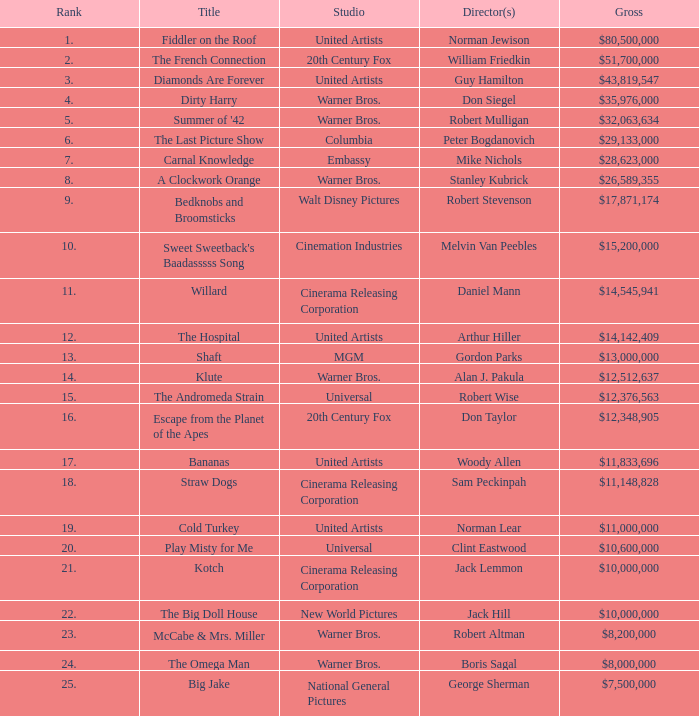What position does the big doll house hold in terms of ranking? 22.0. Give me the full table as a dictionary. {'header': ['Rank', 'Title', 'Studio', 'Director(s)', 'Gross'], 'rows': [['1.', 'Fiddler on the Roof', 'United Artists', 'Norman Jewison', '$80,500,000'], ['2.', 'The French Connection', '20th Century Fox', 'William Friedkin', '$51,700,000'], ['3.', 'Diamonds Are Forever', 'United Artists', 'Guy Hamilton', '$43,819,547'], ['4.', 'Dirty Harry', 'Warner Bros.', 'Don Siegel', '$35,976,000'], ['5.', "Summer of '42", 'Warner Bros.', 'Robert Mulligan', '$32,063,634'], ['6.', 'The Last Picture Show', 'Columbia', 'Peter Bogdanovich', '$29,133,000'], ['7.', 'Carnal Knowledge', 'Embassy', 'Mike Nichols', '$28,623,000'], ['8.', 'A Clockwork Orange', 'Warner Bros.', 'Stanley Kubrick', '$26,589,355'], ['9.', 'Bedknobs and Broomsticks', 'Walt Disney Pictures', 'Robert Stevenson', '$17,871,174'], ['10.', "Sweet Sweetback's Baadasssss Song", 'Cinemation Industries', 'Melvin Van Peebles', '$15,200,000'], ['11.', 'Willard', 'Cinerama Releasing Corporation', 'Daniel Mann', '$14,545,941'], ['12.', 'The Hospital', 'United Artists', 'Arthur Hiller', '$14,142,409'], ['13.', 'Shaft', 'MGM', 'Gordon Parks', '$13,000,000'], ['14.', 'Klute', 'Warner Bros.', 'Alan J. Pakula', '$12,512,637'], ['15.', 'The Andromeda Strain', 'Universal', 'Robert Wise', '$12,376,563'], ['16.', 'Escape from the Planet of the Apes', '20th Century Fox', 'Don Taylor', '$12,348,905'], ['17.', 'Bananas', 'United Artists', 'Woody Allen', '$11,833,696'], ['18.', 'Straw Dogs', 'Cinerama Releasing Corporation', 'Sam Peckinpah', '$11,148,828'], ['19.', 'Cold Turkey', 'United Artists', 'Norman Lear', '$11,000,000'], ['20.', 'Play Misty for Me', 'Universal', 'Clint Eastwood', '$10,600,000'], ['21.', 'Kotch', 'Cinerama Releasing Corporation', 'Jack Lemmon', '$10,000,000'], ['22.', 'The Big Doll House', 'New World Pictures', 'Jack Hill', '$10,000,000'], ['23.', 'McCabe & Mrs. Miller', 'Warner Bros.', 'Robert Altman', '$8,200,000'], ['24.', 'The Omega Man', 'Warner Bros.', 'Boris Sagal', '$8,000,000'], ['25.', 'Big Jake', 'National General Pictures', 'George Sherman', '$7,500,000']]} 